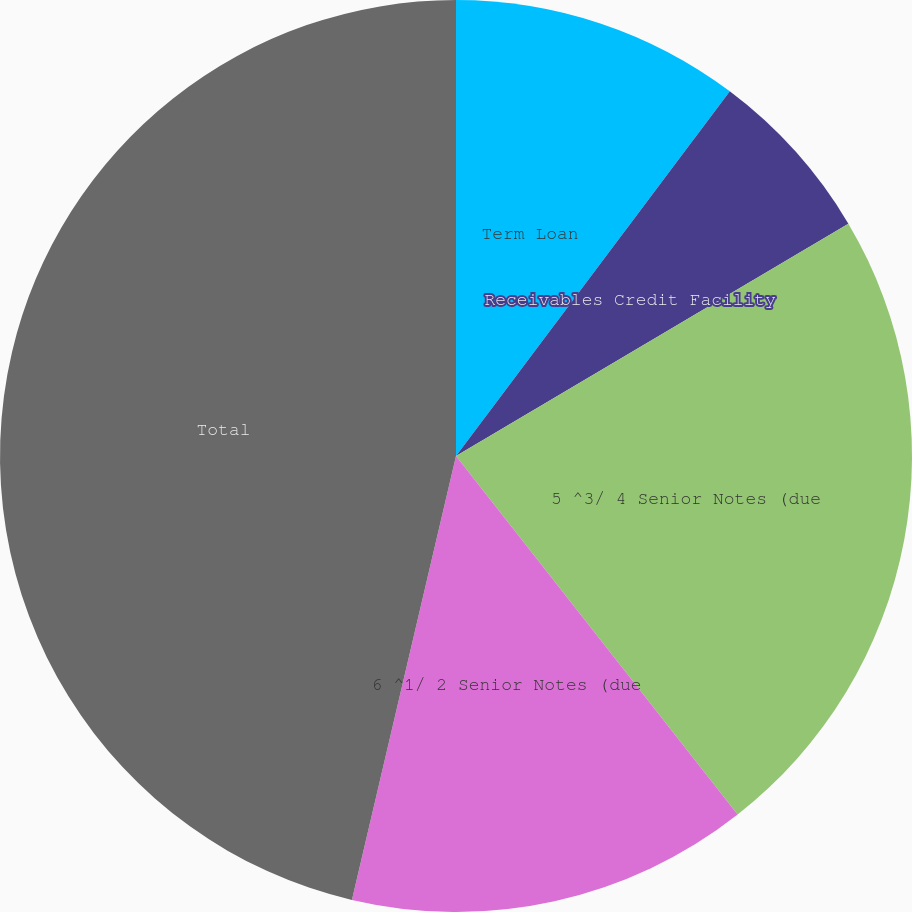Convert chart to OTSL. <chart><loc_0><loc_0><loc_500><loc_500><pie_chart><fcel>Term Loan<fcel>Receivables Credit Facility<fcel>5 ^3/ 4 Senior Notes (due<fcel>6 ^1/ 2 Senior Notes (due<fcel>Total<nl><fcel>10.25%<fcel>6.24%<fcel>22.91%<fcel>14.26%<fcel>46.33%<nl></chart> 